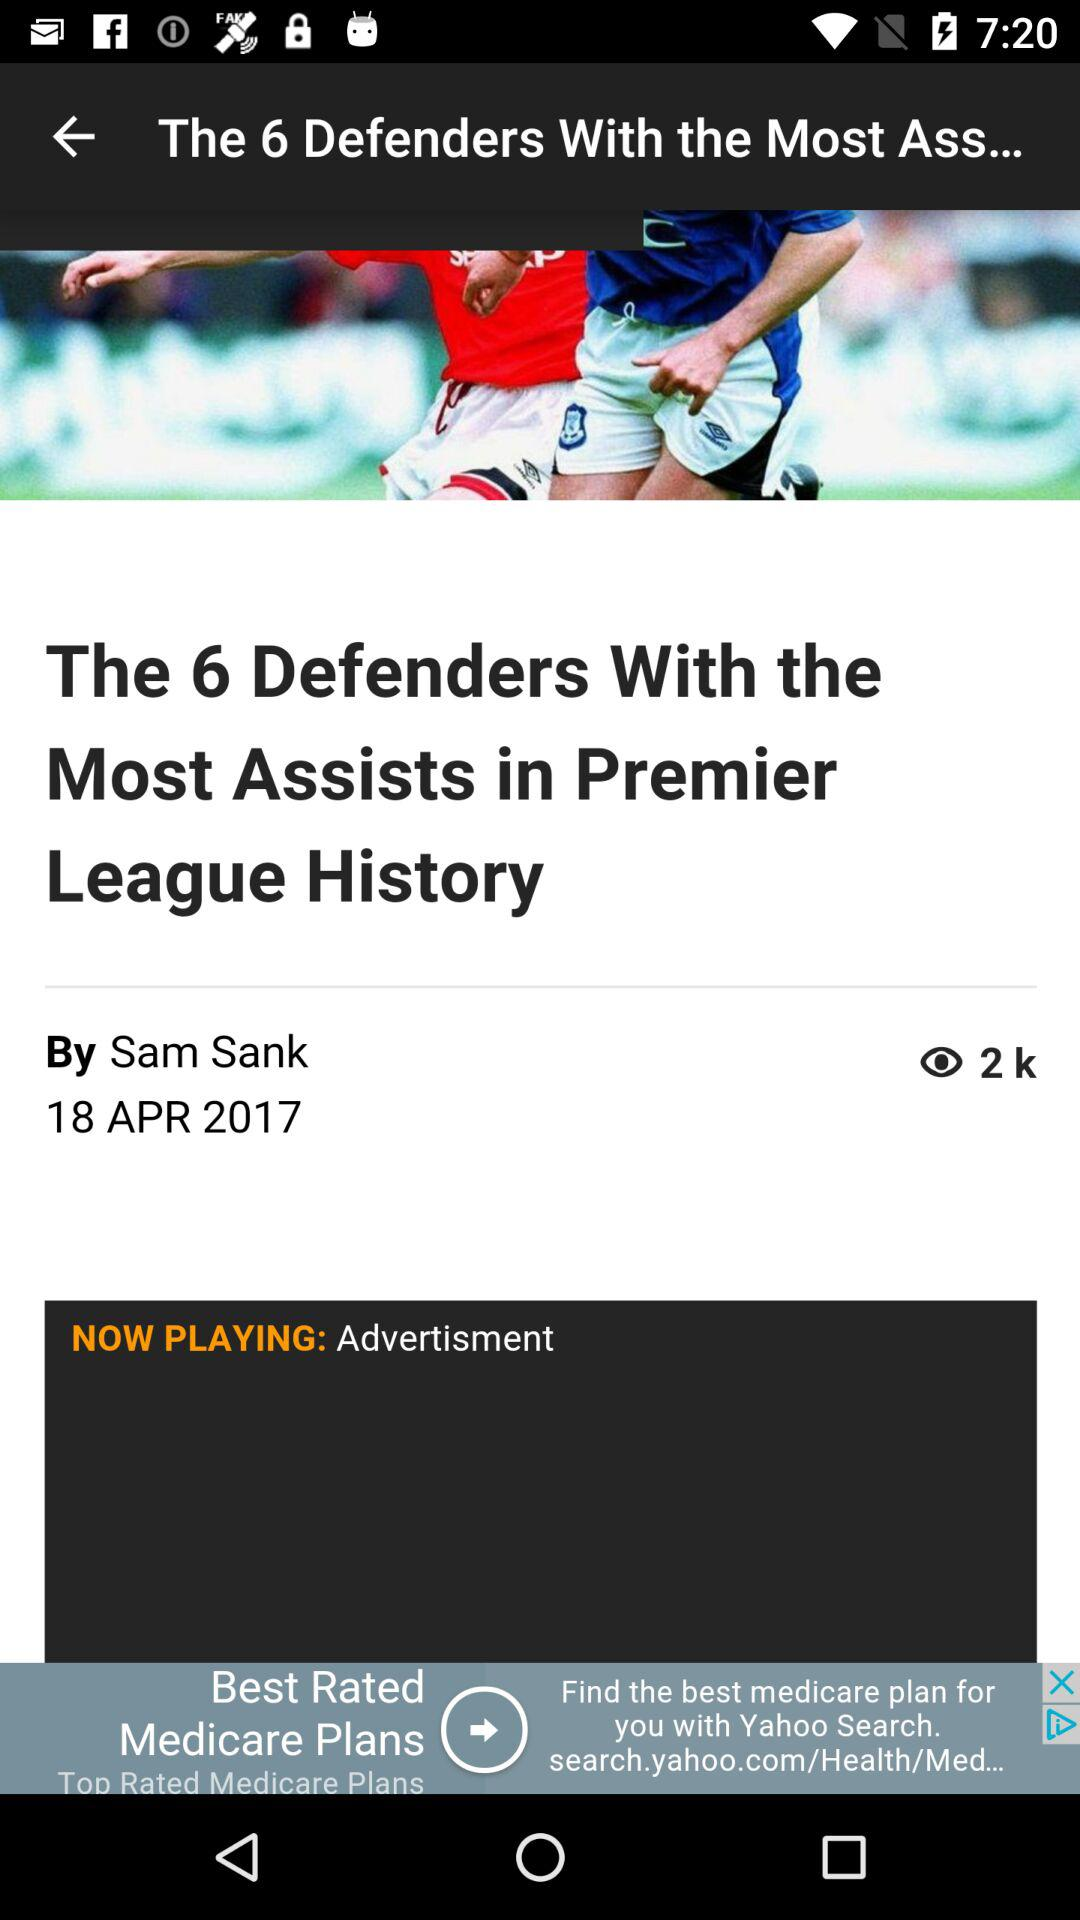What is the headline of the article? The headline of the article is "The 6 Defenders With the Most Assists in Premier League History". 